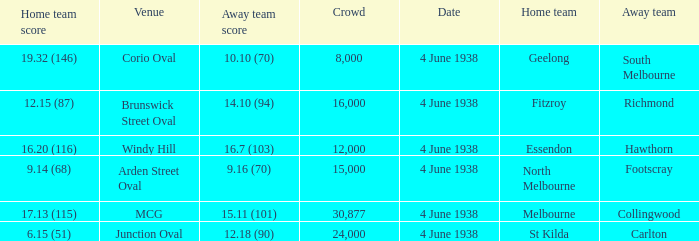How many attended the game at Arden Street Oval? 15000.0. 